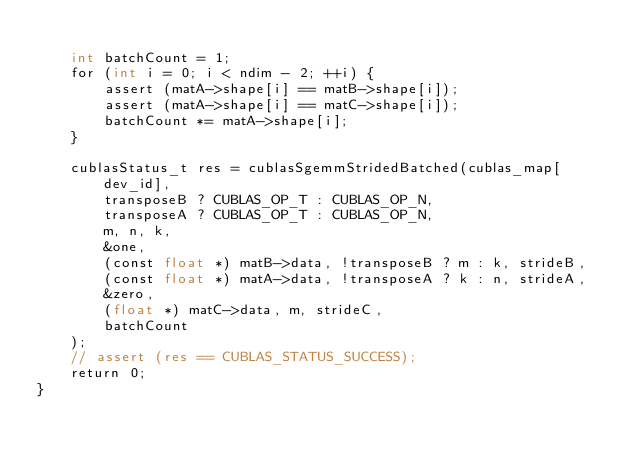<code> <loc_0><loc_0><loc_500><loc_500><_Cuda_>
    int batchCount = 1;
    for (int i = 0; i < ndim - 2; ++i) {
        assert (matA->shape[i] == matB->shape[i]);
        assert (matA->shape[i] == matC->shape[i]);
        batchCount *= matA->shape[i];
    }

    cublasStatus_t res = cublasSgemmStridedBatched(cublas_map[dev_id], 
        transposeB ? CUBLAS_OP_T : CUBLAS_OP_N,
        transposeA ? CUBLAS_OP_T : CUBLAS_OP_N,
        m, n, k,
        &one,
        (const float *) matB->data, !transposeB ? m : k, strideB,
        (const float *) matA->data, !transposeA ? k : n, strideA,
        &zero,
        (float *) matC->data, m, strideC,
        batchCount
    );
    // assert (res == CUBLAS_STATUS_SUCCESS);
    return 0;    
}</code> 